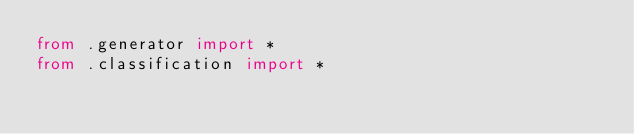<code> <loc_0><loc_0><loc_500><loc_500><_Python_>from .generator import *
from .classification import *
</code> 